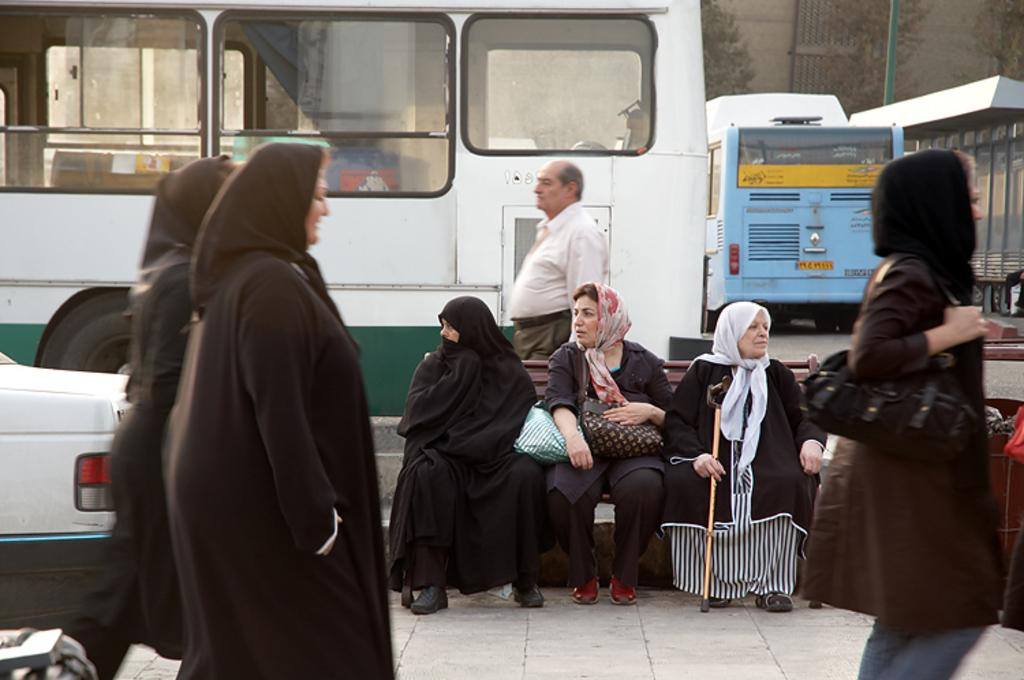Who or what can be seen in the image? There are people in the image. What are some of the people doing in the image? Some people are sitting on a bench. What else can be seen in the image besides people? There are vehicles and trees visible in the image. What can be seen in the background of the image? There is a building in the background of the image. What type of fork can be seen in the image? There is no fork present in the image. Is there a birthday celebration happening in the image? There is no indication of a birthday celebration in the image. 